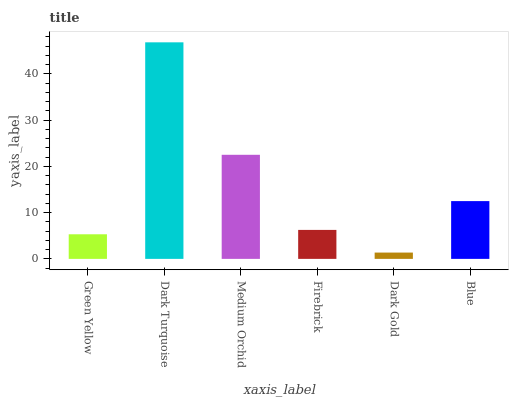Is Dark Gold the minimum?
Answer yes or no. Yes. Is Dark Turquoise the maximum?
Answer yes or no. Yes. Is Medium Orchid the minimum?
Answer yes or no. No. Is Medium Orchid the maximum?
Answer yes or no. No. Is Dark Turquoise greater than Medium Orchid?
Answer yes or no. Yes. Is Medium Orchid less than Dark Turquoise?
Answer yes or no. Yes. Is Medium Orchid greater than Dark Turquoise?
Answer yes or no. No. Is Dark Turquoise less than Medium Orchid?
Answer yes or no. No. Is Blue the high median?
Answer yes or no. Yes. Is Firebrick the low median?
Answer yes or no. Yes. Is Dark Gold the high median?
Answer yes or no. No. Is Blue the low median?
Answer yes or no. No. 